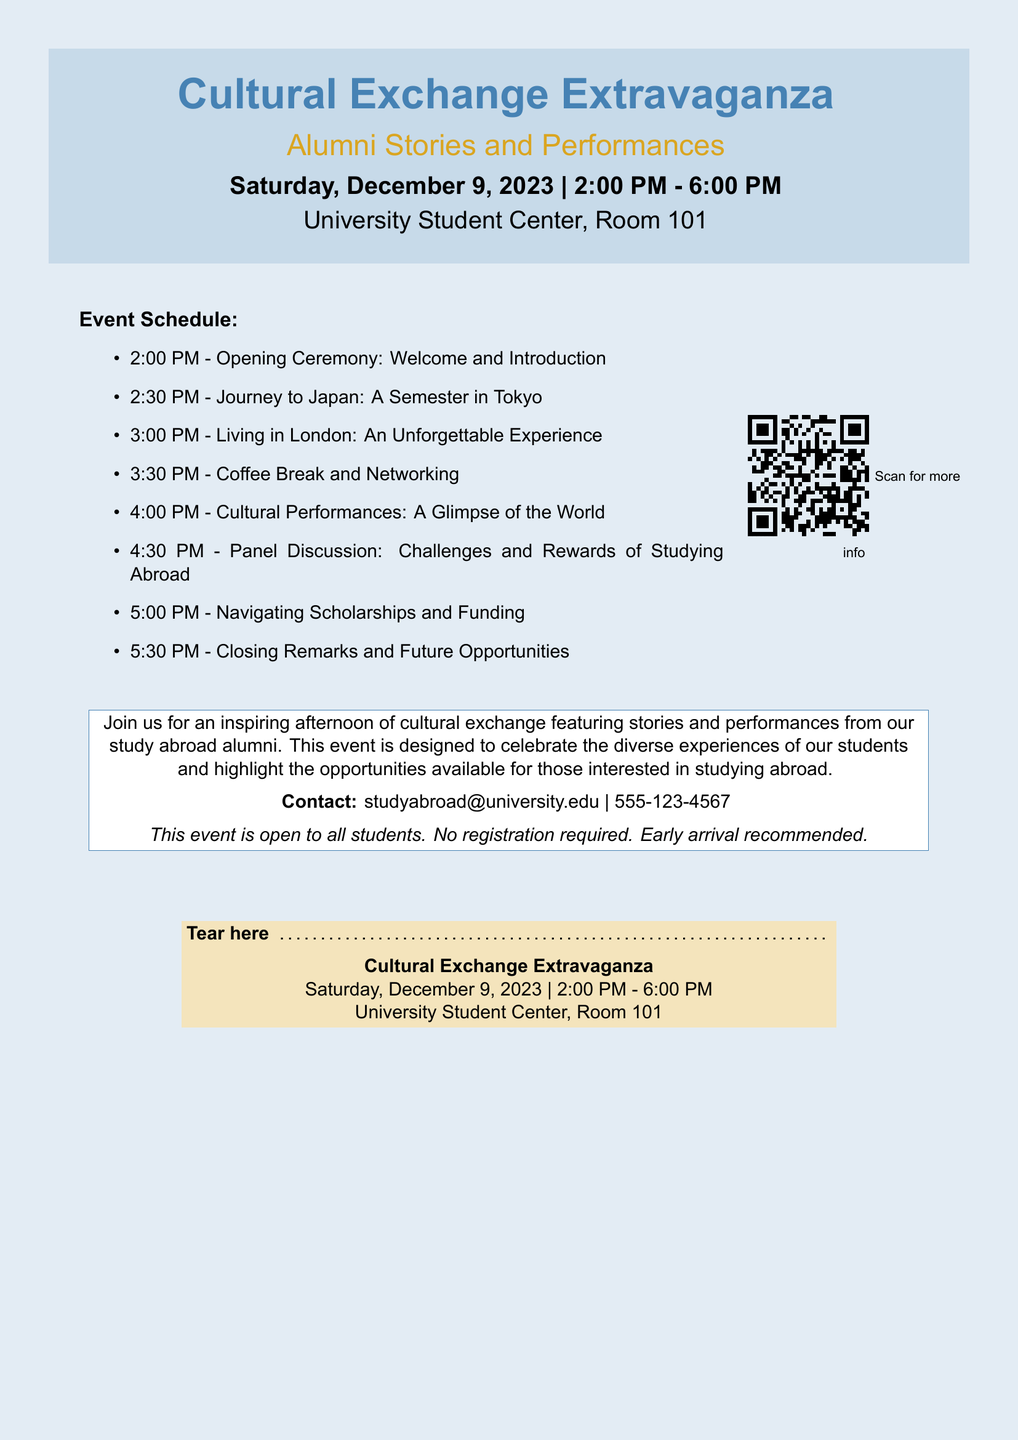What is the event title? The event title as stated in the document is "Cultural Exchange Extravaganza."
Answer: Cultural Exchange Extravaganza When is the event scheduled? The document specifies the event date as Saturday, December 9, 2023.
Answer: December 9, 2023 What time does the event start? The document indicates that the event starts at 2:00 PM.
Answer: 2:00 PM Which university location will host the event? According to the document, the event will take place at "University Student Center, Room 101."
Answer: University Student Center, Room 101 What type of performances will be featured? The document mentions "Cultural Performances" will be part of the event.
Answer: Cultural Performances What is one of the topics in the panel discussion? The document lists "Challenges and Rewards of Studying Abroad" as a panel discussion topic.
Answer: Challenges and Rewards of Studying Abroad Is registration required to attend the event? The document states that "No registration required."
Answer: No What should attendees consider regarding arrival? The document advises that "Early arrival recommended."
Answer: Early arrival recommended What is the contact email for more information? The document provides the contact email as "studyabroad@university.edu."
Answer: studyabroad@university.edu 